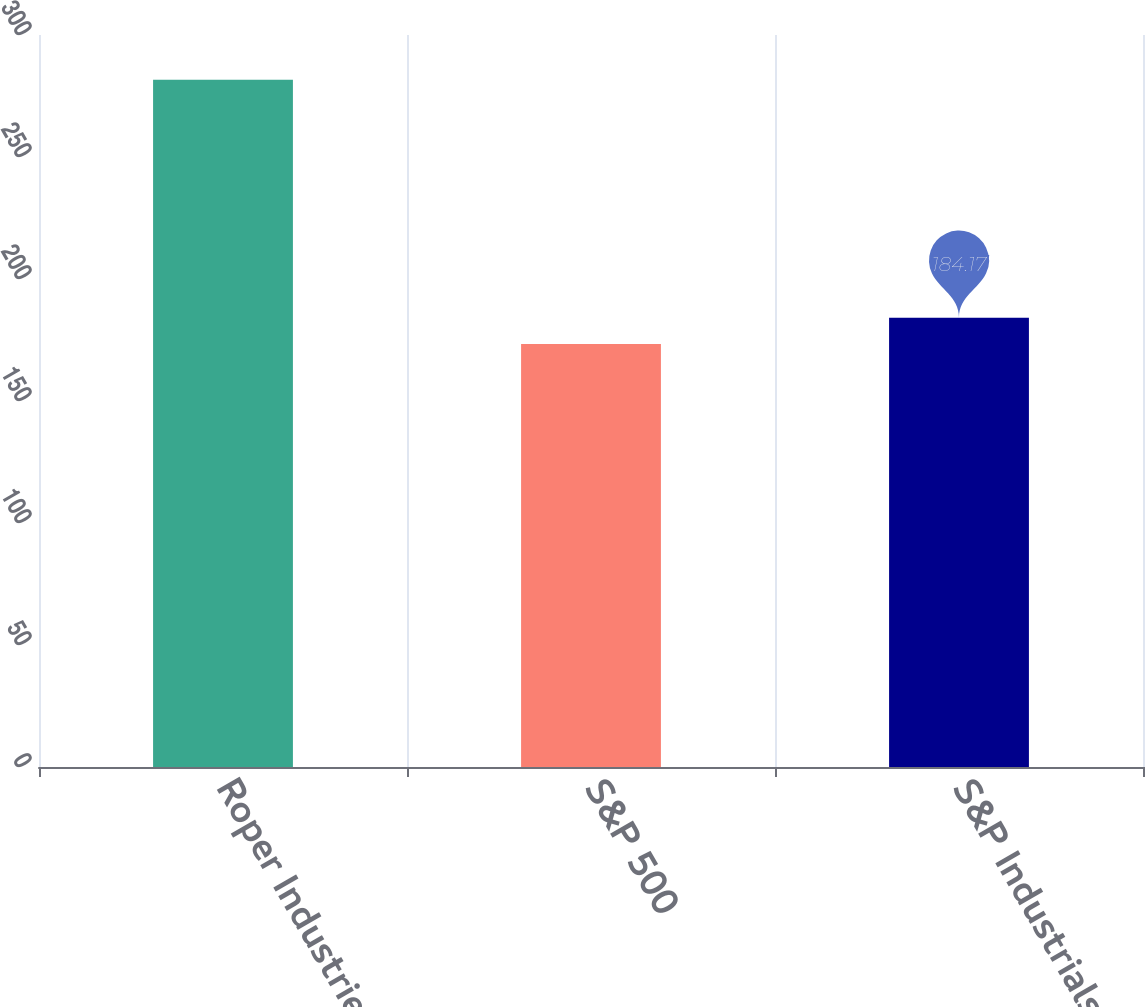Convert chart to OTSL. <chart><loc_0><loc_0><loc_500><loc_500><bar_chart><fcel>Roper Industries Inc<fcel>S&P 500<fcel>S&P Industrials<nl><fcel>281.64<fcel>173.34<fcel>184.17<nl></chart> 